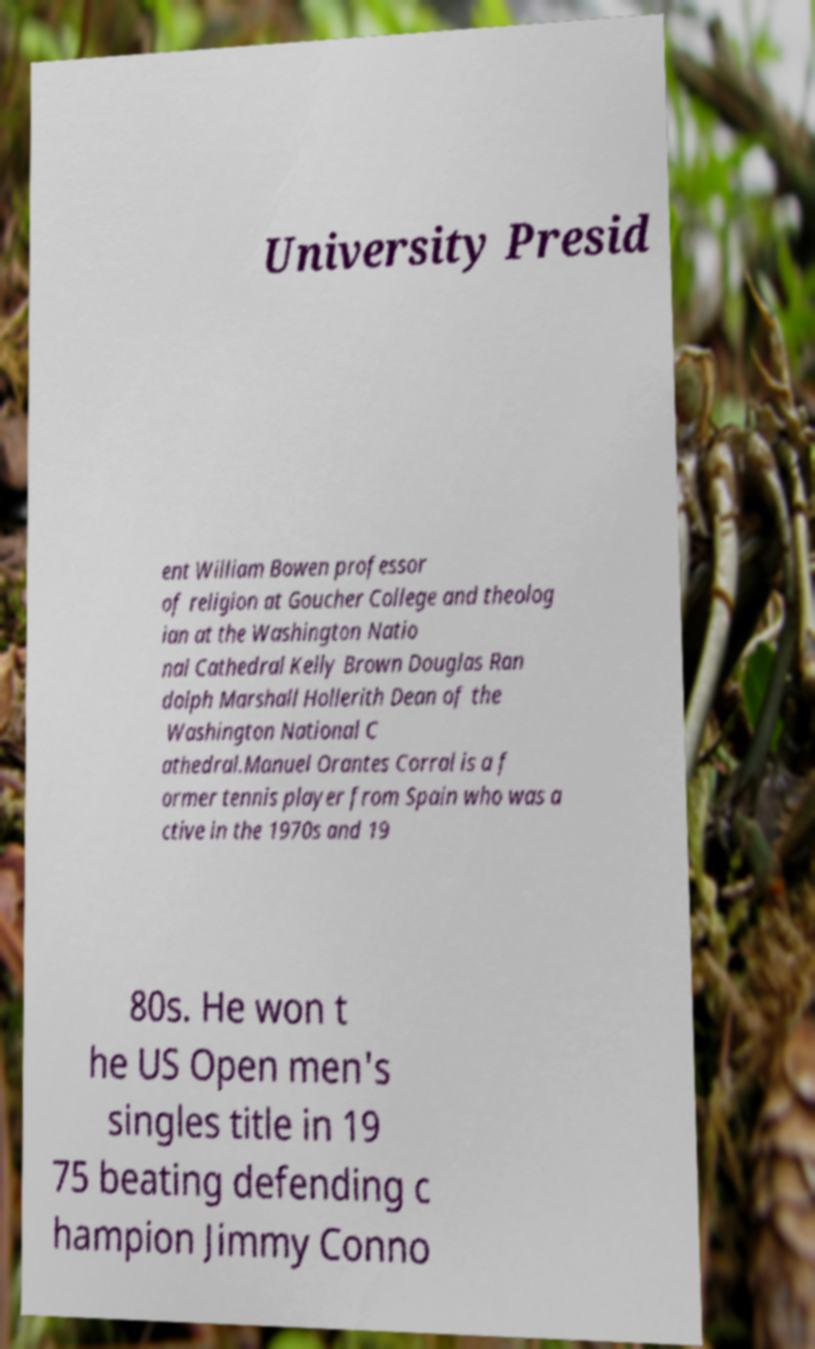There's text embedded in this image that I need extracted. Can you transcribe it verbatim? University Presid ent William Bowen professor of religion at Goucher College and theolog ian at the Washington Natio nal Cathedral Kelly Brown Douglas Ran dolph Marshall Hollerith Dean of the Washington National C athedral.Manuel Orantes Corral is a f ormer tennis player from Spain who was a ctive in the 1970s and 19 80s. He won t he US Open men's singles title in 19 75 beating defending c hampion Jimmy Conno 